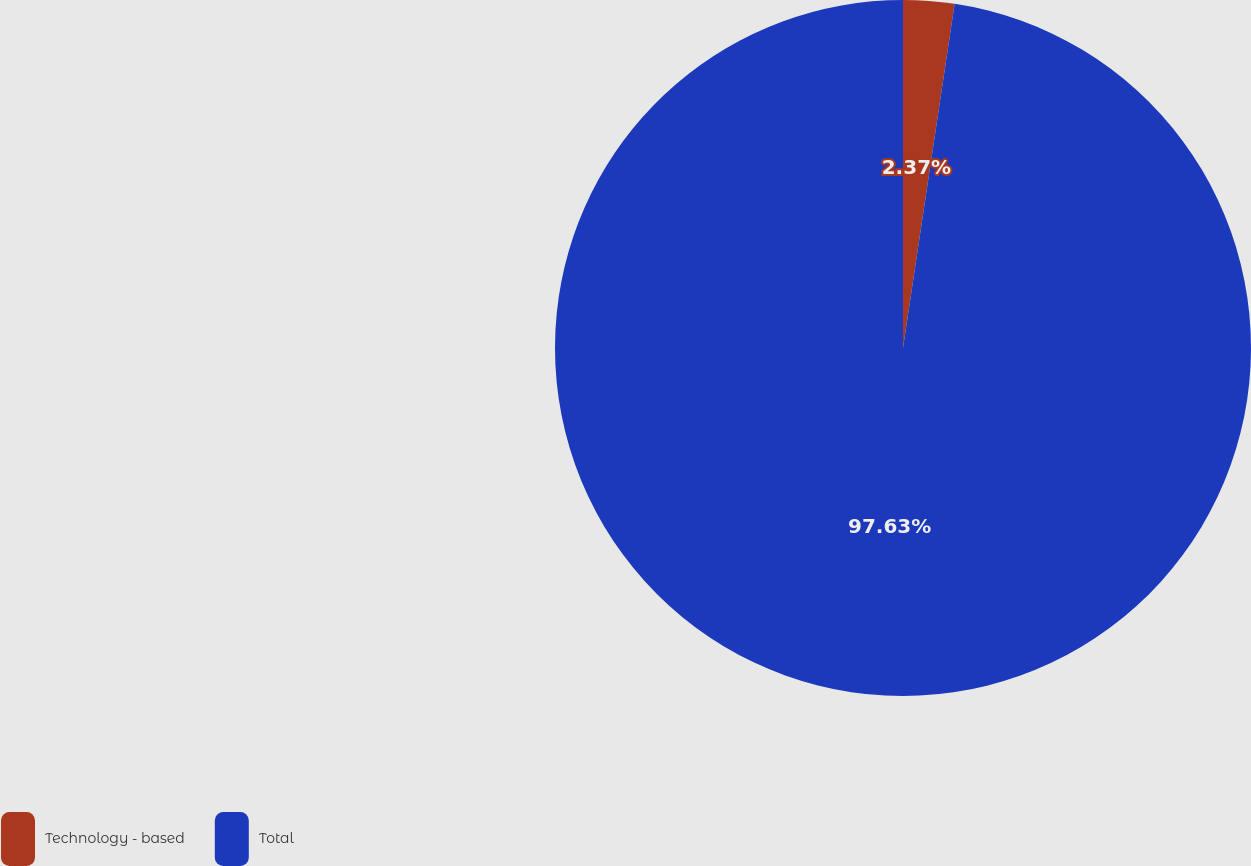<chart> <loc_0><loc_0><loc_500><loc_500><pie_chart><fcel>Technology - based<fcel>Total<nl><fcel>2.37%<fcel>97.63%<nl></chart> 